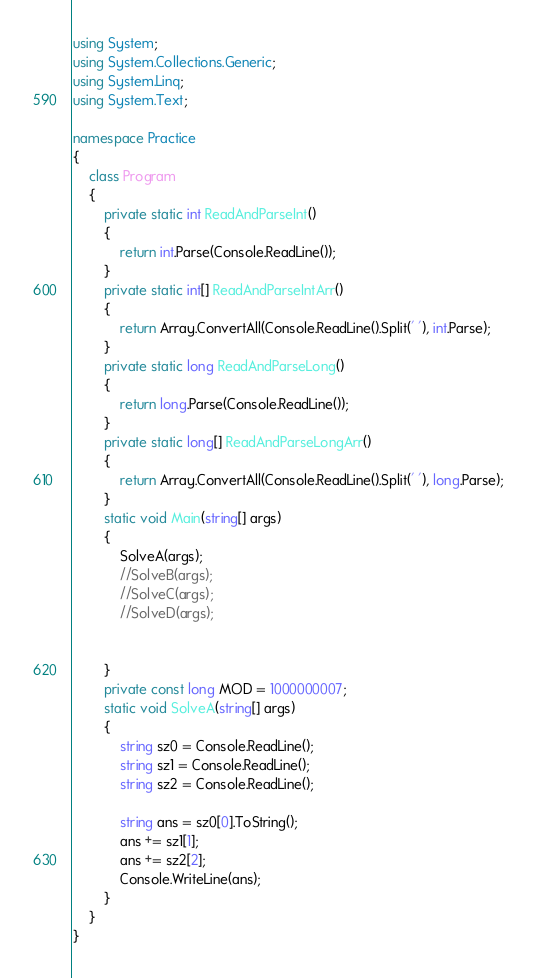Convert code to text. <code><loc_0><loc_0><loc_500><loc_500><_C#_>using System;
using System.Collections.Generic;
using System.Linq;
using System.Text;

namespace Practice
{
    class Program
    {
        private static int ReadAndParseInt()
        {
            return int.Parse(Console.ReadLine());
        }
        private static int[] ReadAndParseIntArr()
        {
            return Array.ConvertAll(Console.ReadLine().Split(' '), int.Parse);
        }
        private static long ReadAndParseLong()
        {
            return long.Parse(Console.ReadLine());
        }
        private static long[] ReadAndParseLongArr()
        {
            return Array.ConvertAll(Console.ReadLine().Split(' '), long.Parse);
        }
        static void Main(string[] args)
        {
            SolveA(args);
            //SolveB(args);
            //SolveC(args);
            //SolveD(args);


        }
        private const long MOD = 1000000007;
        static void SolveA(string[] args)
        {
            string sz0 = Console.ReadLine();
            string sz1 = Console.ReadLine();
            string sz2 = Console.ReadLine();

            string ans = sz0[0].ToString();
            ans += sz1[1];
            ans += sz2[2];
            Console.WriteLine(ans);
        }
    }
}</code> 